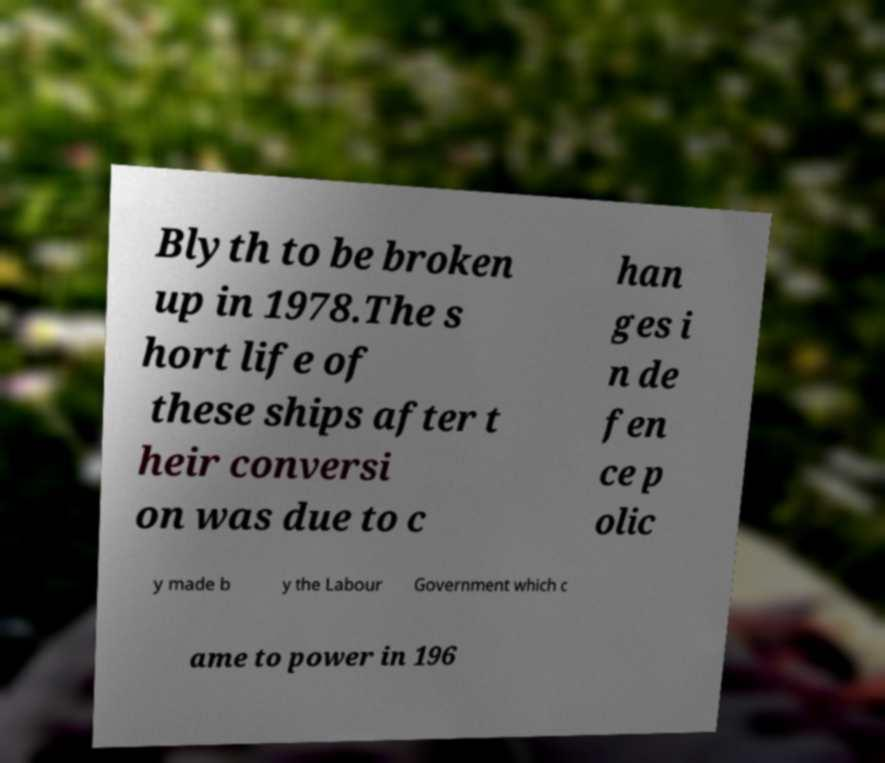Can you accurately transcribe the text from the provided image for me? Blyth to be broken up in 1978.The s hort life of these ships after t heir conversi on was due to c han ges i n de fen ce p olic y made b y the Labour Government which c ame to power in 196 